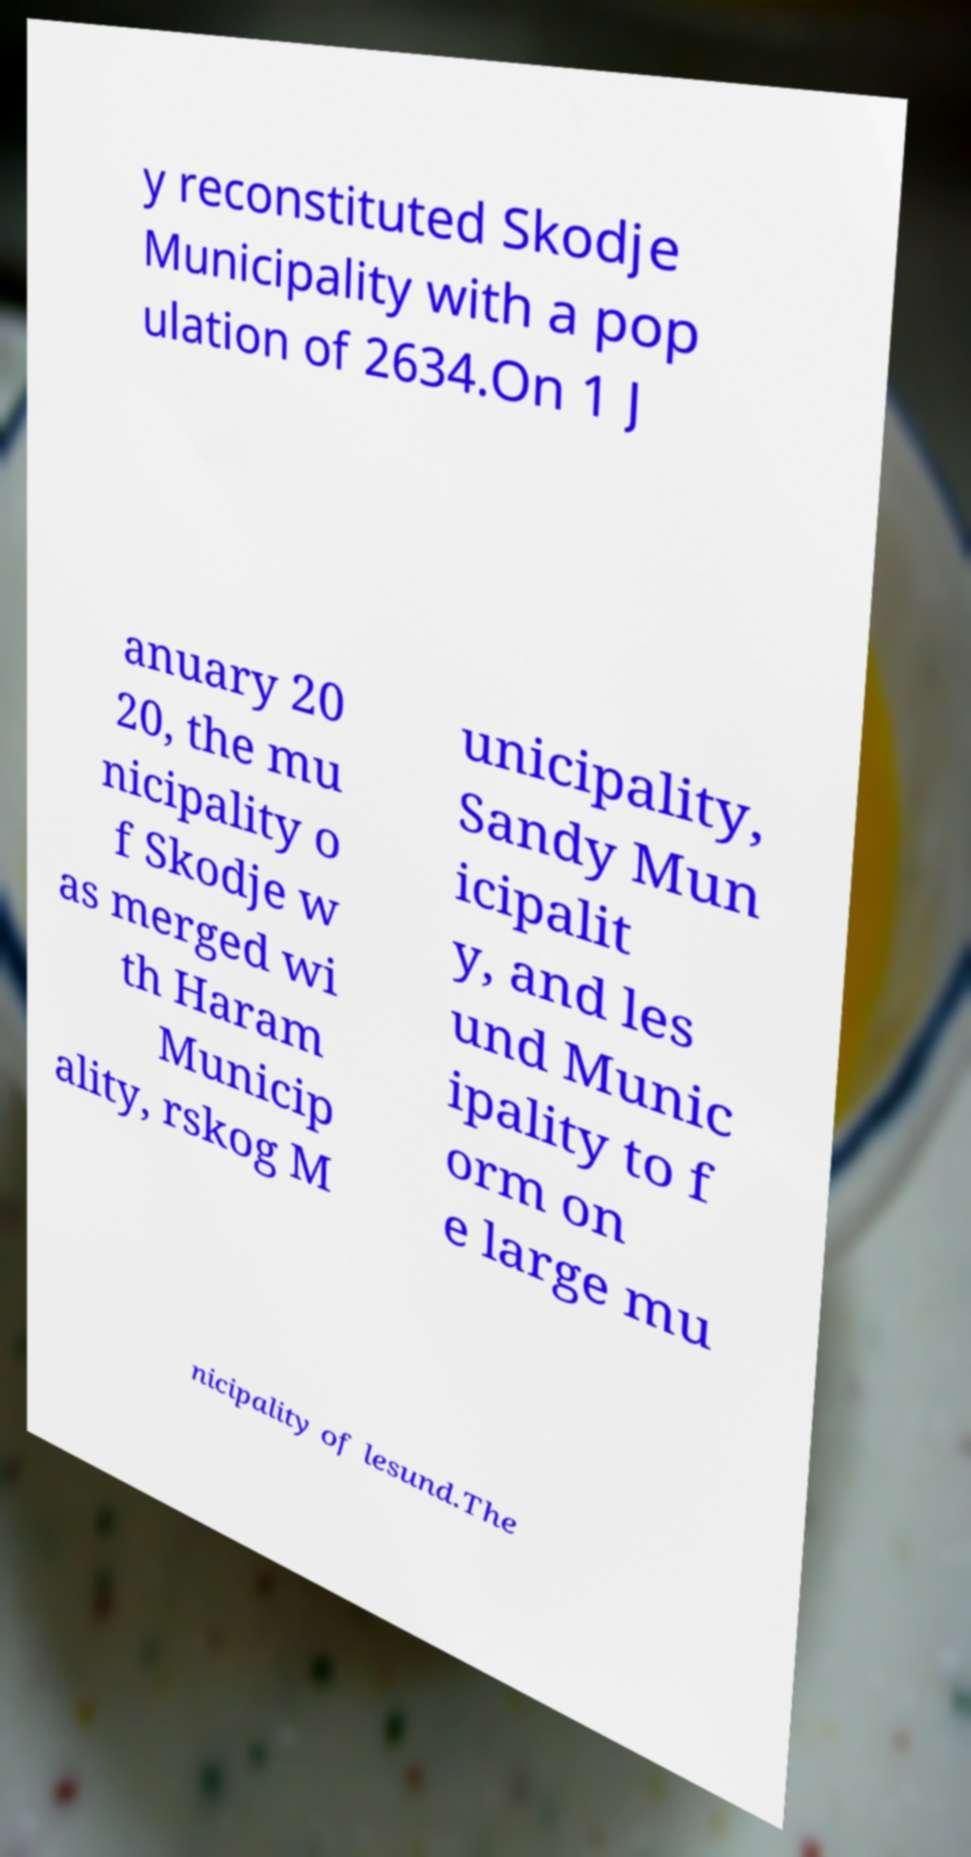Could you assist in decoding the text presented in this image and type it out clearly? y reconstituted Skodje Municipality with a pop ulation of 2634.On 1 J anuary 20 20, the mu nicipality o f Skodje w as merged wi th Haram Municip ality, rskog M unicipality, Sandy Mun icipalit y, and les und Munic ipality to f orm on e large mu nicipality of lesund.The 